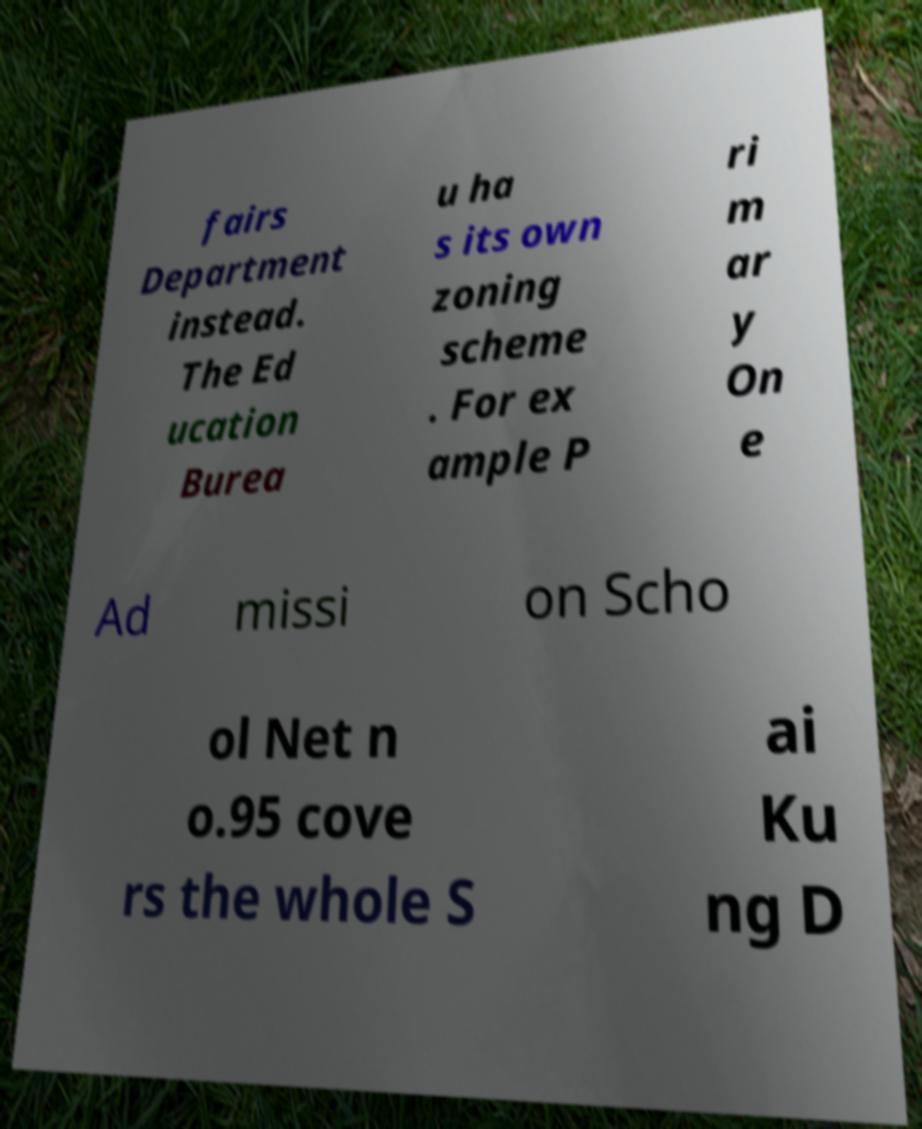For documentation purposes, I need the text within this image transcribed. Could you provide that? fairs Department instead. The Ed ucation Burea u ha s its own zoning scheme . For ex ample P ri m ar y On e Ad missi on Scho ol Net n o.95 cove rs the whole S ai Ku ng D 